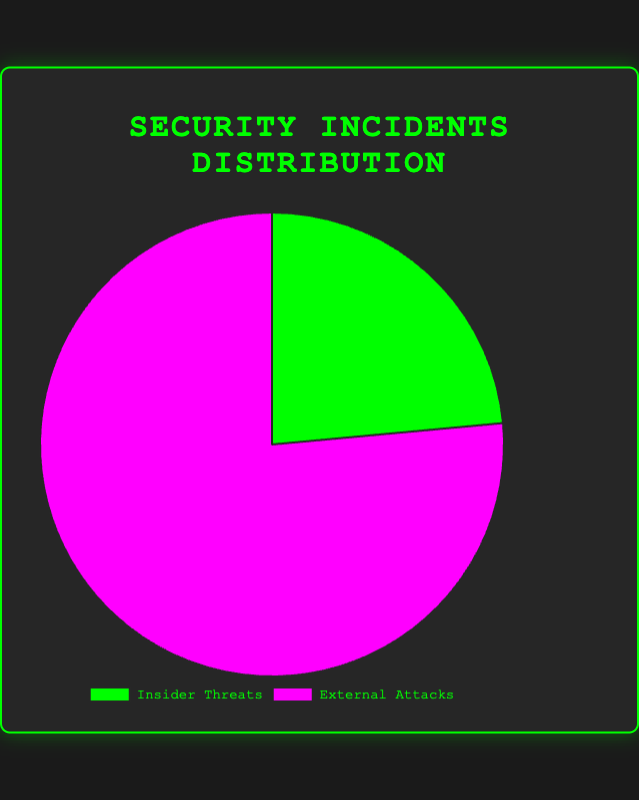What percentage of security incidents are caused by Insider Threats? To find the percentage of incidents caused by Insider Threats, we can use the given data. The total number of security incidents is 400 (Insider Threats) + 1300 (External Attacks) = 1700. The percentage is calculated as (400 / 1700) * 100%.
Answer: ~23.5% What's the ratio of External Attacks to Insider Threats? The ratio can be found by dividing the number of External Attacks by the number of Insider Threats. We have 1300 External Attacks and 400 Insider Threats, so the ratio is 1300 / 400.
Answer: 3.25 Which type of threat has a higher number of incidents? According to the pie chart, External Attacks have 1300 incidents, while Insider Threats have 400 incidents. Since 1300 is greater than 400, External Attacks have a higher number of incidents.
Answer: External Attacks How many more incidents are caused by External Attacks compared to Insider Threats? To find the difference, subtract the number of Insider Threats from the number of External Attacks. This is calculated as 1300 - 400.
Answer: 900 What is the total number of security incidents? The total number is the sum of incidents caused by both Insider Threats and External Attacks, which is 400 + 1300.
Answer: 1700 If we combine careless employee incidents with phishing attacks, how many incidents are there in total? Careless employee incidents are 200, and phishing attack incidents are 400. Their combined total is 200 + 400.
Answer: 600 How does the number of incidents caused by disgruntled employees compare to ransomware incidents? Disgruntled employee incidents are 150, and ransomware incidents are 300. Since 300 is greater than 150, ransomware incidents are higher.
Answer: Ransomware What percentage of the security incidents are caused by careless employees among Insider Threats? Within Insider Threats, the total number of incidents is 150 (Disgruntled Employees) + 200 (Careless Employees) + 50 (Third-party Contractors) = 400. The number of incidents caused by careless employees is 200. The percentage is (200 / 400) * 100%.
Answer: 50% What percentage of External Attacks are due to malware? Within External Attacks, the total number of incidents is 400 (Phishing Attacks) + 600 (Malware) + 300 (Ransomware) = 1300. The number of incidents caused by malware is 600. The percentage is (600 / 1300) * 100%.
Answer: ~46.2% Which has more incidents: Third-party Contractors as an Insider Threat or Phishing Attacks as an External Attack? According to the data, incidents from Third-party Contractors are 50, and incidents from Phishing Attacks are 400. Since 400 is greater than 50, Phishing Attacks as an External Attack have more incidents.
Answer: Phishing Attacks 